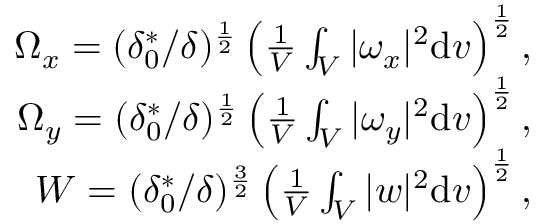Convert formula to latex. <formula><loc_0><loc_0><loc_500><loc_500>\begin{array} { r } { \Omega _ { x } = ( \delta _ { 0 } ^ { * } / \delta ) ^ { \frac { 1 } { 2 } } \left ( \frac { 1 } { V } \int _ { V } | \omega _ { x } | ^ { 2 } \mathrm d v \right ) ^ { \frac { 1 } { 2 } } , } \\ { \Omega _ { y } = ( \delta _ { 0 } ^ { * } / \delta ) ^ { \frac { 1 } { 2 } } \left ( \frac { 1 } { V } \int _ { V } | \omega _ { y } | ^ { 2 } \mathrm d v \right ) ^ { \frac { 1 } { 2 } } , } \\ { W = ( \delta _ { 0 } ^ { * } / \delta ) ^ { \frac { 3 } { 2 } } \left ( \frac { 1 } { V } \int _ { V } | w | ^ { 2 } \mathrm d v \right ) ^ { \frac { 1 } { 2 } } , } \end{array}</formula> 